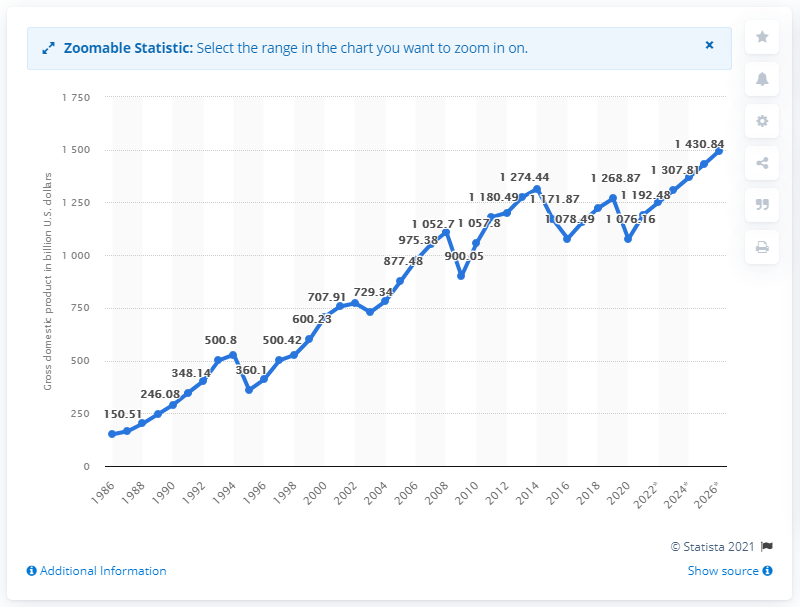Give some essential details in this illustration. In 2020, the Gross Domestic Product (GDP) of Mexico was 1,076.16 billion dollars. 